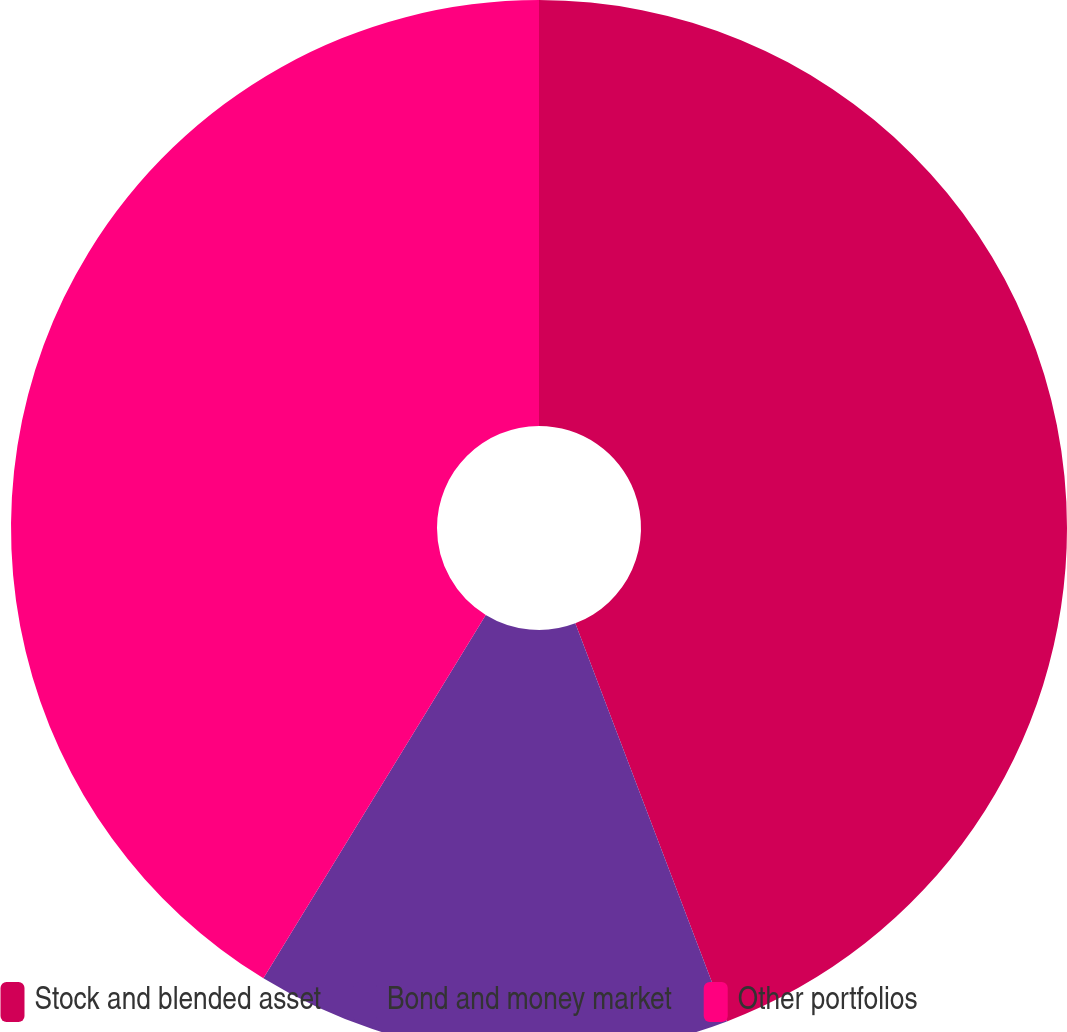Convert chart. <chart><loc_0><loc_0><loc_500><loc_500><pie_chart><fcel>Stock and blended asset<fcel>Bond and money market<fcel>Other portfolios<nl><fcel>44.21%<fcel>14.53%<fcel>41.26%<nl></chart> 